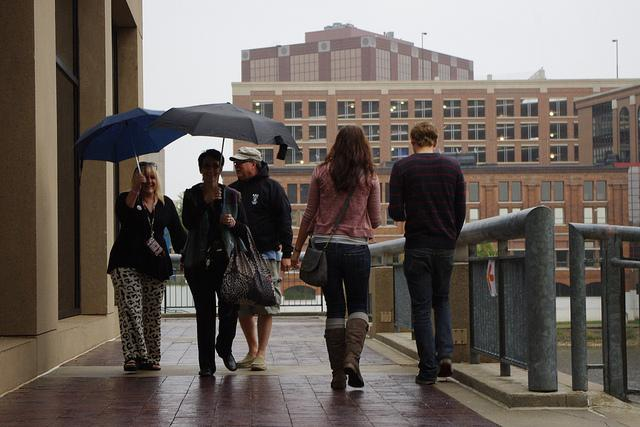What problem are the two people on the right facing? Please explain your reasoning. getting soaked. The people don't have something to cover themselves. 